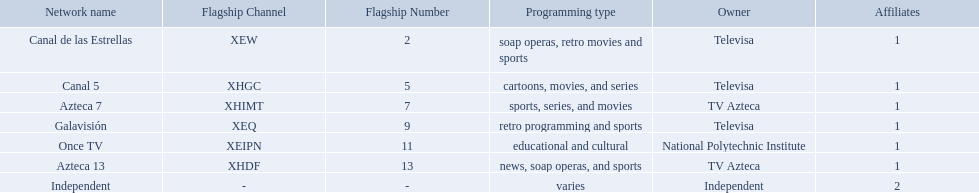What station shows cartoons? Canal 5. What station shows soap operas? Canal de las Estrellas. What station shows sports? Azteca 7. What television stations are in morelos? Canal de las Estrellas, Canal 5, Azteca 7, Galavisión, Once TV, Azteca 13, Independent. Of those which network is owned by national polytechnic institute? Once TV. Which owner only owns one network? National Polytechnic Institute, Independent. Of those, what is the network name? Once TV, Independent. Of those, which programming type is educational and cultural? Once TV. Who are the owners of the stations listed here? Televisa, Televisa, TV Azteca, Televisa, National Polytechnic Institute, TV Azteca, Independent. What is the one station owned by national polytechnic institute? Once TV. 